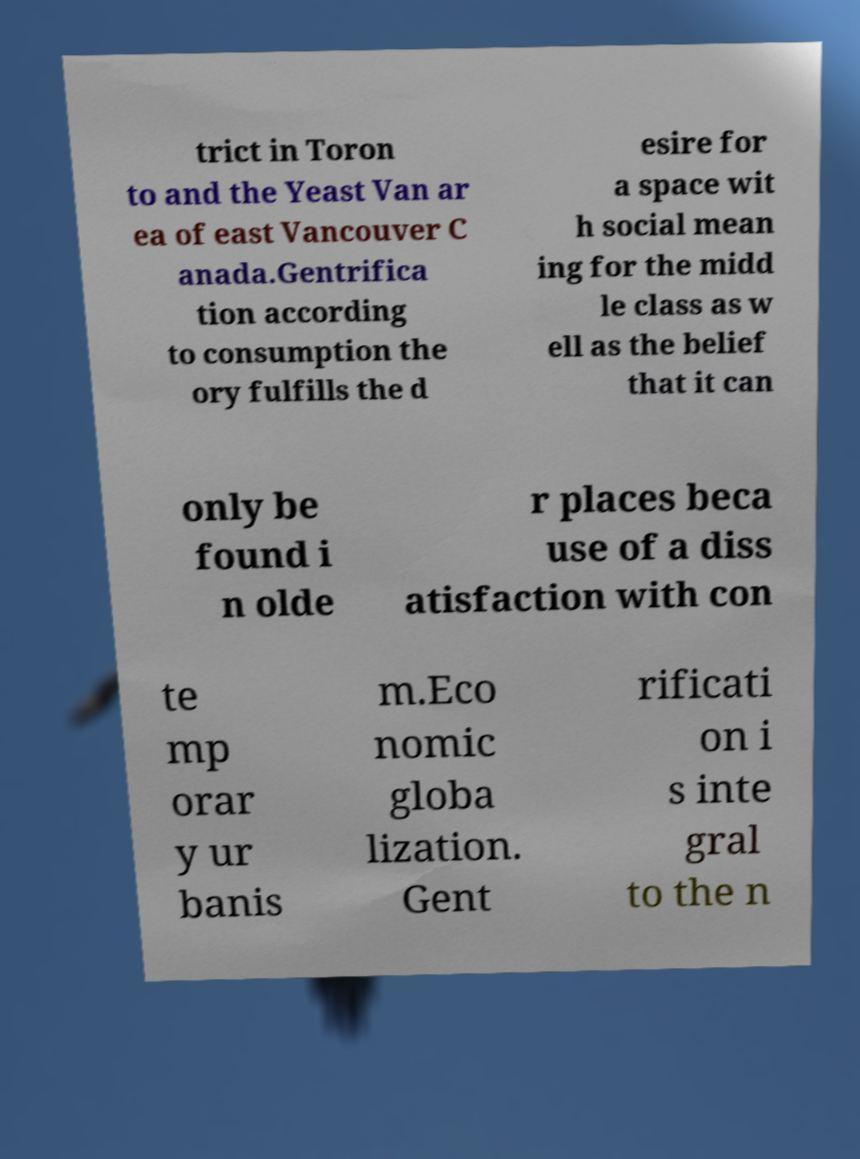Could you extract and type out the text from this image? trict in Toron to and the Yeast Van ar ea of east Vancouver C anada.Gentrifica tion according to consumption the ory fulfills the d esire for a space wit h social mean ing for the midd le class as w ell as the belief that it can only be found i n olde r places beca use of a diss atisfaction with con te mp orar y ur banis m.Eco nomic globa lization. Gent rificati on i s inte gral to the n 